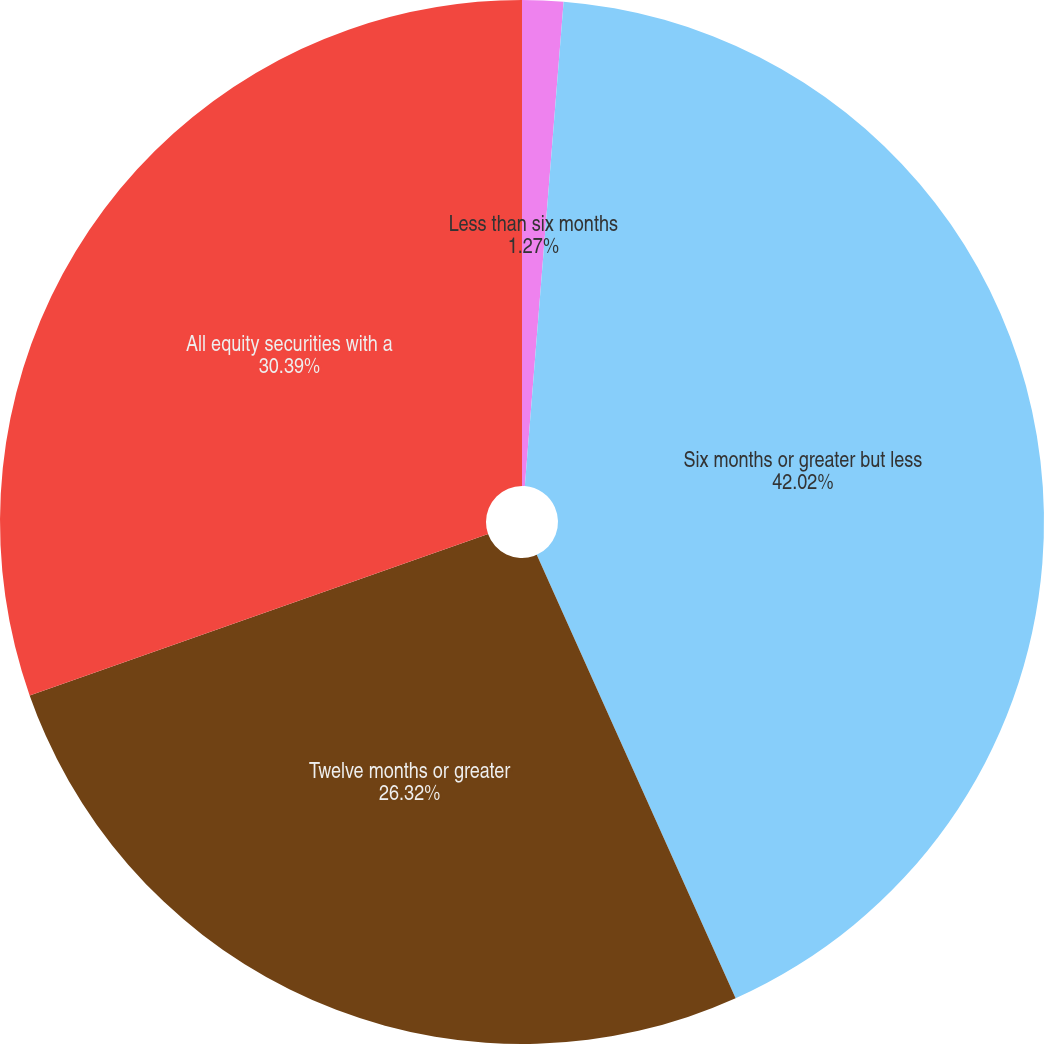Convert chart. <chart><loc_0><loc_0><loc_500><loc_500><pie_chart><fcel>Less than six months<fcel>Six months or greater but less<fcel>Twelve months or greater<fcel>All equity securities with a<nl><fcel>1.27%<fcel>42.02%<fcel>26.32%<fcel>30.39%<nl></chart> 